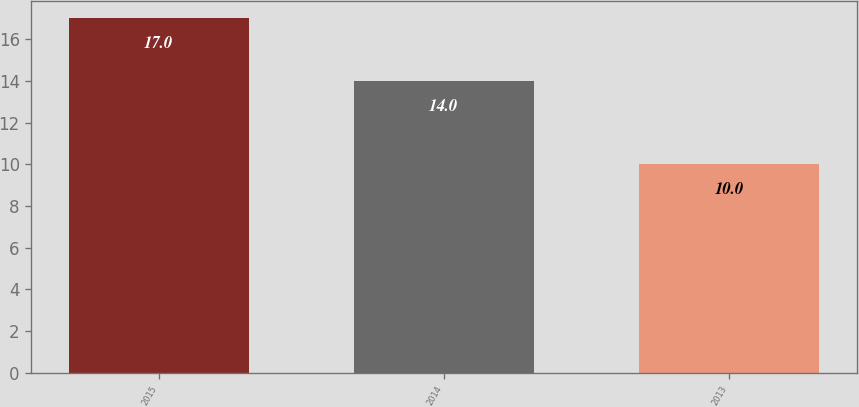Convert chart. <chart><loc_0><loc_0><loc_500><loc_500><bar_chart><fcel>2015<fcel>2014<fcel>2013<nl><fcel>17<fcel>14<fcel>10<nl></chart> 